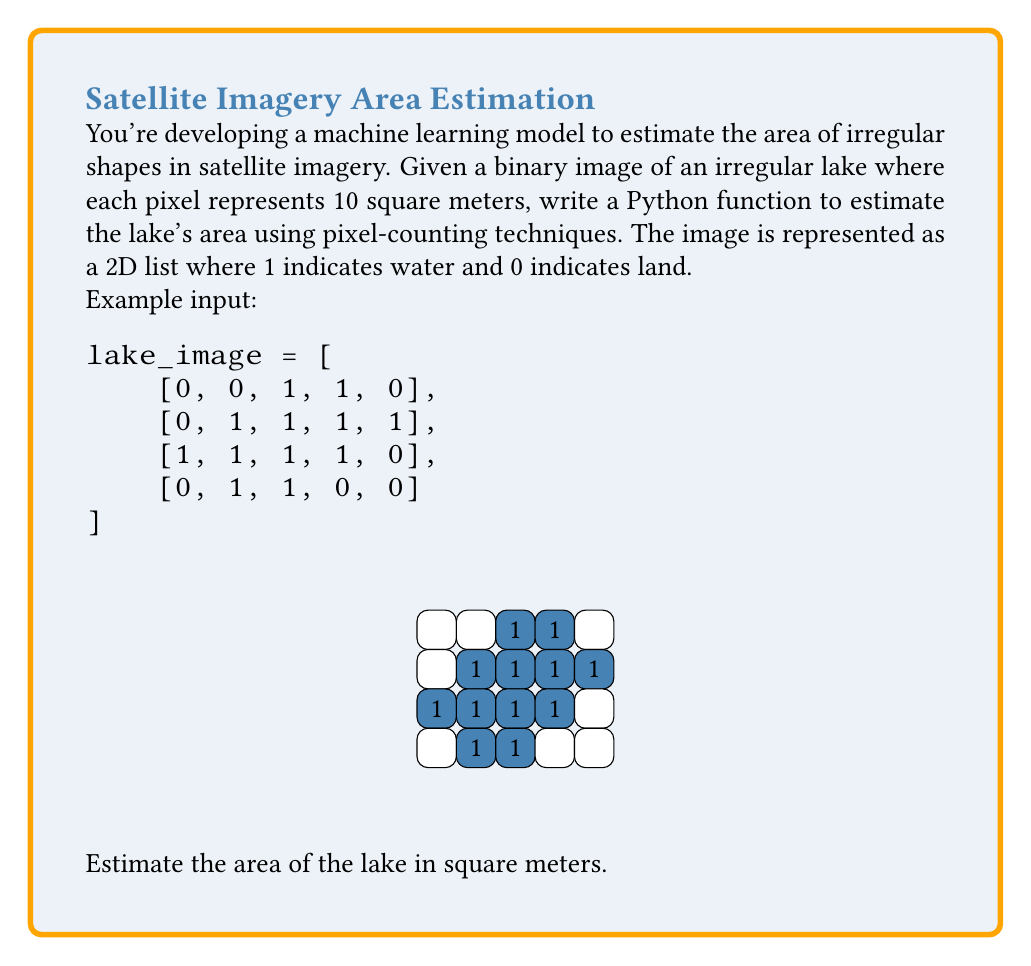Give your solution to this math problem. To solve this problem, we'll follow these steps:

1. Write a function to count the number of water pixels (1's) in the image.
2. Multiply the count by the area represented by each pixel.

Here's the Python function to count water pixels:

```python
def count_water_pixels(image):
    return sum(row.count(1) for row in image)
```

Now, let's apply this to our problem:

1. Count the water pixels:
   $$\text{water_pixels} = count\_water\_pixels(lake\_image) = 12$$

2. Calculate the area:
   Each pixel represents 10 square meters, so:
   $$\text{area} = \text{water_pixels} \times 10 \text{ m}^2$$
   $$\text{area} = 12 \times 10 \text{ m}^2 = 120 \text{ m}^2$$

This pixel-counting technique provides an estimate of the irregular lake's area. The accuracy depends on the resolution of the image (pixel size) and how well the pixels capture the lake's boundaries.
Answer: 120 m² 